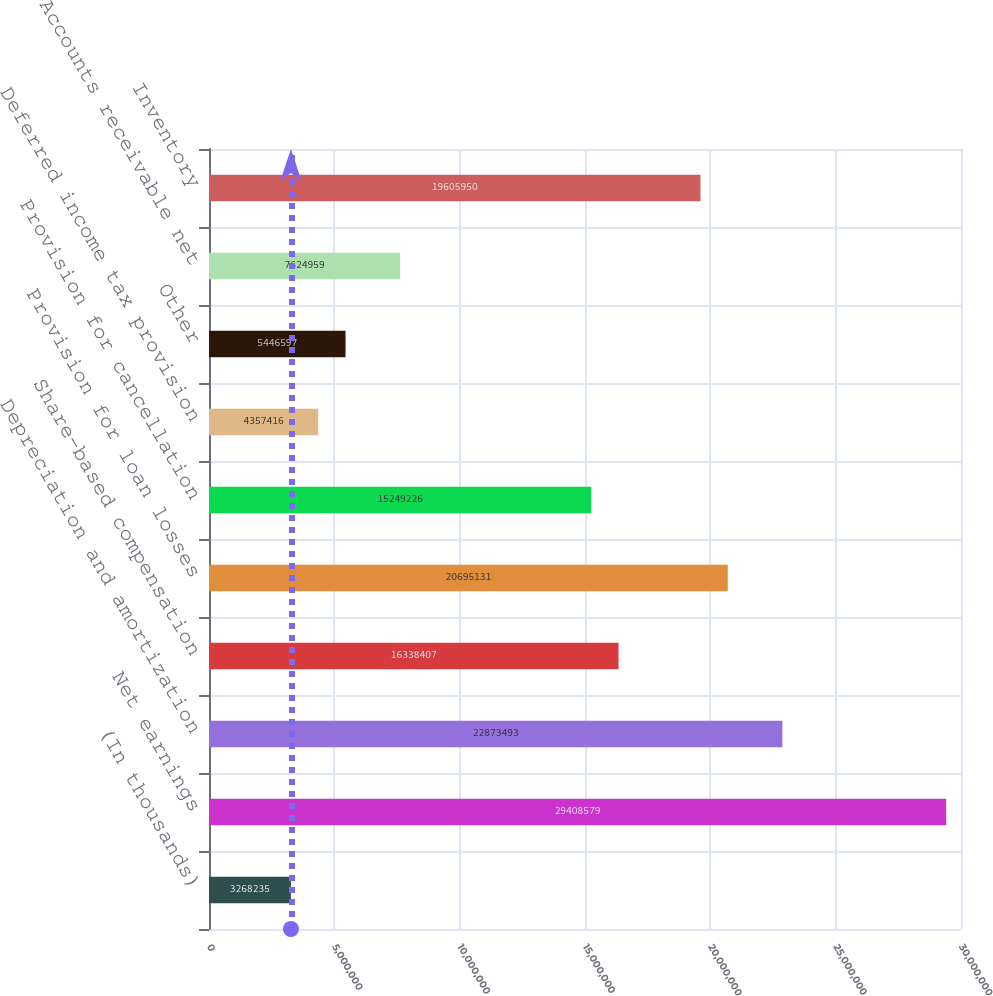<chart> <loc_0><loc_0><loc_500><loc_500><bar_chart><fcel>(In thousands)<fcel>Net earnings<fcel>Depreciation and amortization<fcel>Share-based compensation<fcel>Provision for loan losses<fcel>Provision for cancellation<fcel>Deferred income tax provision<fcel>Other<fcel>Accounts receivable net<fcel>Inventory<nl><fcel>3.26824e+06<fcel>2.94086e+07<fcel>2.28735e+07<fcel>1.63384e+07<fcel>2.06951e+07<fcel>1.52492e+07<fcel>4.35742e+06<fcel>5.4466e+06<fcel>7.62496e+06<fcel>1.9606e+07<nl></chart> 